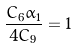Convert formula to latex. <formula><loc_0><loc_0><loc_500><loc_500>\frac { C _ { 6 } \alpha _ { 1 } } { 4 C _ { 9 } } = 1</formula> 